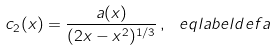Convert formula to latex. <formula><loc_0><loc_0><loc_500><loc_500>c _ { 2 } ( x ) = \frac { a ( x ) } { ( 2 x - x ^ { 2 } ) ^ { 1 / 3 } } \, , \ e q l a b e l { d e f a }</formula> 